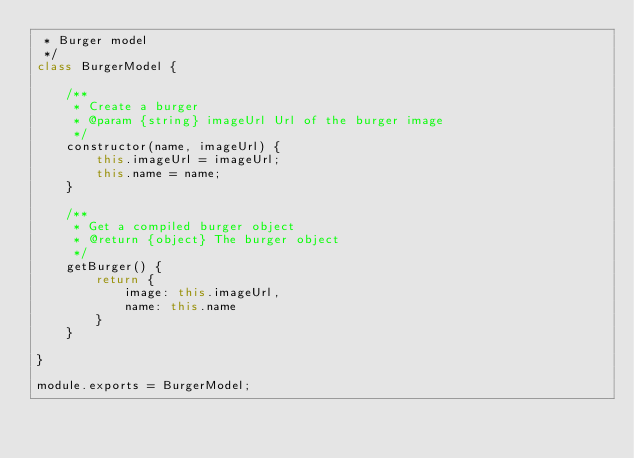<code> <loc_0><loc_0><loc_500><loc_500><_JavaScript_> * Burger model
 */
class BurgerModel {
	
	/**
	 * Create a burger
	 * @param {string} imageUrl Url of the burger image
	 */
	constructor(name, imageUrl) {
		this.imageUrl = imageUrl;
		this.name = name;
	}
	
	/**
	 * Get a compiled burger object
	 * @return {object} The burger object
	 */
	getBurger() {
		return { 
			image: this.imageUrl,
			name: this.name
		}
	}
	
}

module.exports = BurgerModel;</code> 